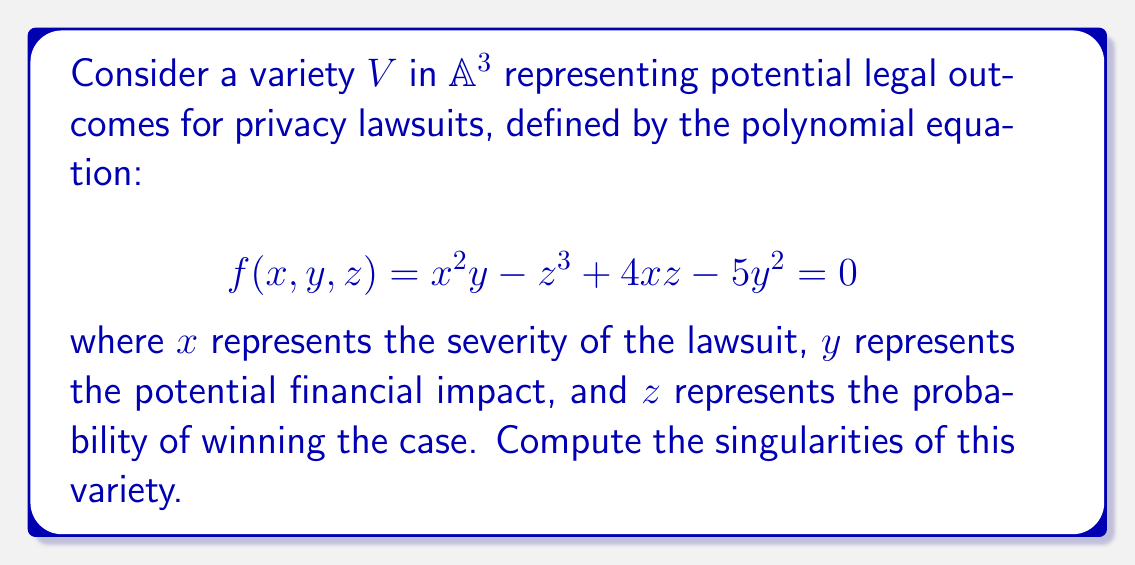Help me with this question. To find the singularities of the variety $V$, we need to follow these steps:

1) Calculate the partial derivatives of $f$ with respect to $x$, $y$, and $z$:

   $$\frac{\partial f}{\partial x} = 2xy + 4z$$
   $$\frac{\partial f}{\partial y} = x^2 - 10y$$
   $$\frac{\partial f}{\partial z} = -3z^2 + 4x$$

2) A point $(x,y,z)$ is singular if it satisfies both:
   a) $f(x,y,z) = 0$
   b) $\frac{\partial f}{\partial x} = \frac{\partial f}{\partial y} = \frac{\partial f}{\partial z} = 0$

3) From $\frac{\partial f}{\partial y} = 0$, we get:
   $x^2 = 10y$

4) From $\frac{\partial f}{\partial x} = 0$:
   $2xy = -4z$
   Substituting $y = \frac{x^2}{10}$:
   $\frac{x^3}{5} = -4z$
   $z = -\frac{x^3}{20}$

5) From $\frac{\partial f}{\partial z} = 0$:
   $-3z^2 + 4x = 0$
   Substituting $z = -\frac{x^3}{20}$:
   $-3(\frac{x^3}{20})^2 + 4x = 0$
   $-3\frac{x^6}{400} + 4x = 0$
   $-3x^6 + 1600x = 0$
   $x(-3x^5 + 1600) = 0$

6) Solving this equation, we get $x = 0$ or $x = 4$

7) When $x = 0$, $y = z = 0$
   When $x = 4$, $y = \frac{16}{10} = 1.6$ and $z = -\frac{64}{20} = -3.2$

8) Verify these points satisfy $f(x,y,z) = 0$:
   For (0,0,0): $f(0,0,0) = 0$
   For (4,1.6,-3.2): $f(4,1.6,-3.2) = 4^2(1.6) - (-3.2)^3 + 4(4)(-3.2) - 5(1.6)^2 = 0$

Therefore, the singularities are (0,0,0) and (4,1.6,-3.2).
Answer: (0,0,0) and (4,1.6,-3.2) 